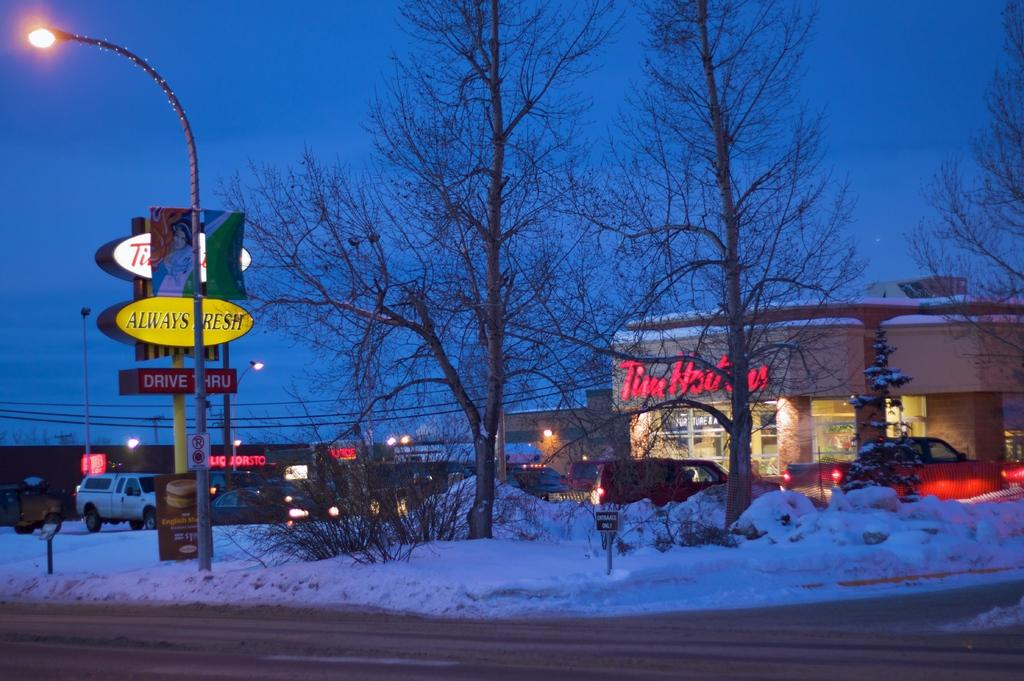<image>
Describe the image concisely. the name Tim Horton that is on a building 